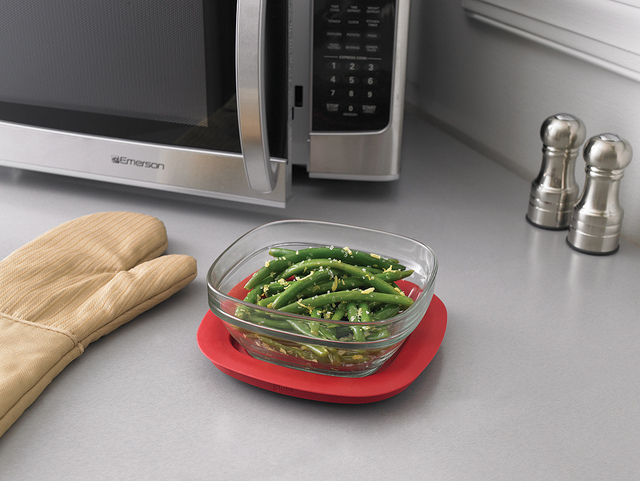What is the bowl of green beans sitting on? The bowl of green beans is resting on a circular red silicone pot holder to protect surfaces from heat. 